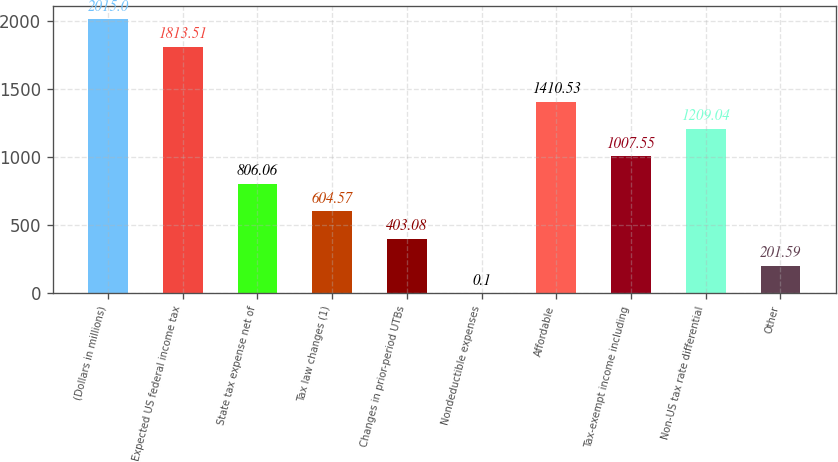<chart> <loc_0><loc_0><loc_500><loc_500><bar_chart><fcel>(Dollars in millions)<fcel>Expected US federal income tax<fcel>State tax expense net of<fcel>Tax law changes (1)<fcel>Changes in prior-period UTBs<fcel>Nondeductible expenses<fcel>Affordable<fcel>Tax-exempt income including<fcel>Non-US tax rate differential<fcel>Other<nl><fcel>2015<fcel>1813.51<fcel>806.06<fcel>604.57<fcel>403.08<fcel>0.1<fcel>1410.53<fcel>1007.55<fcel>1209.04<fcel>201.59<nl></chart> 